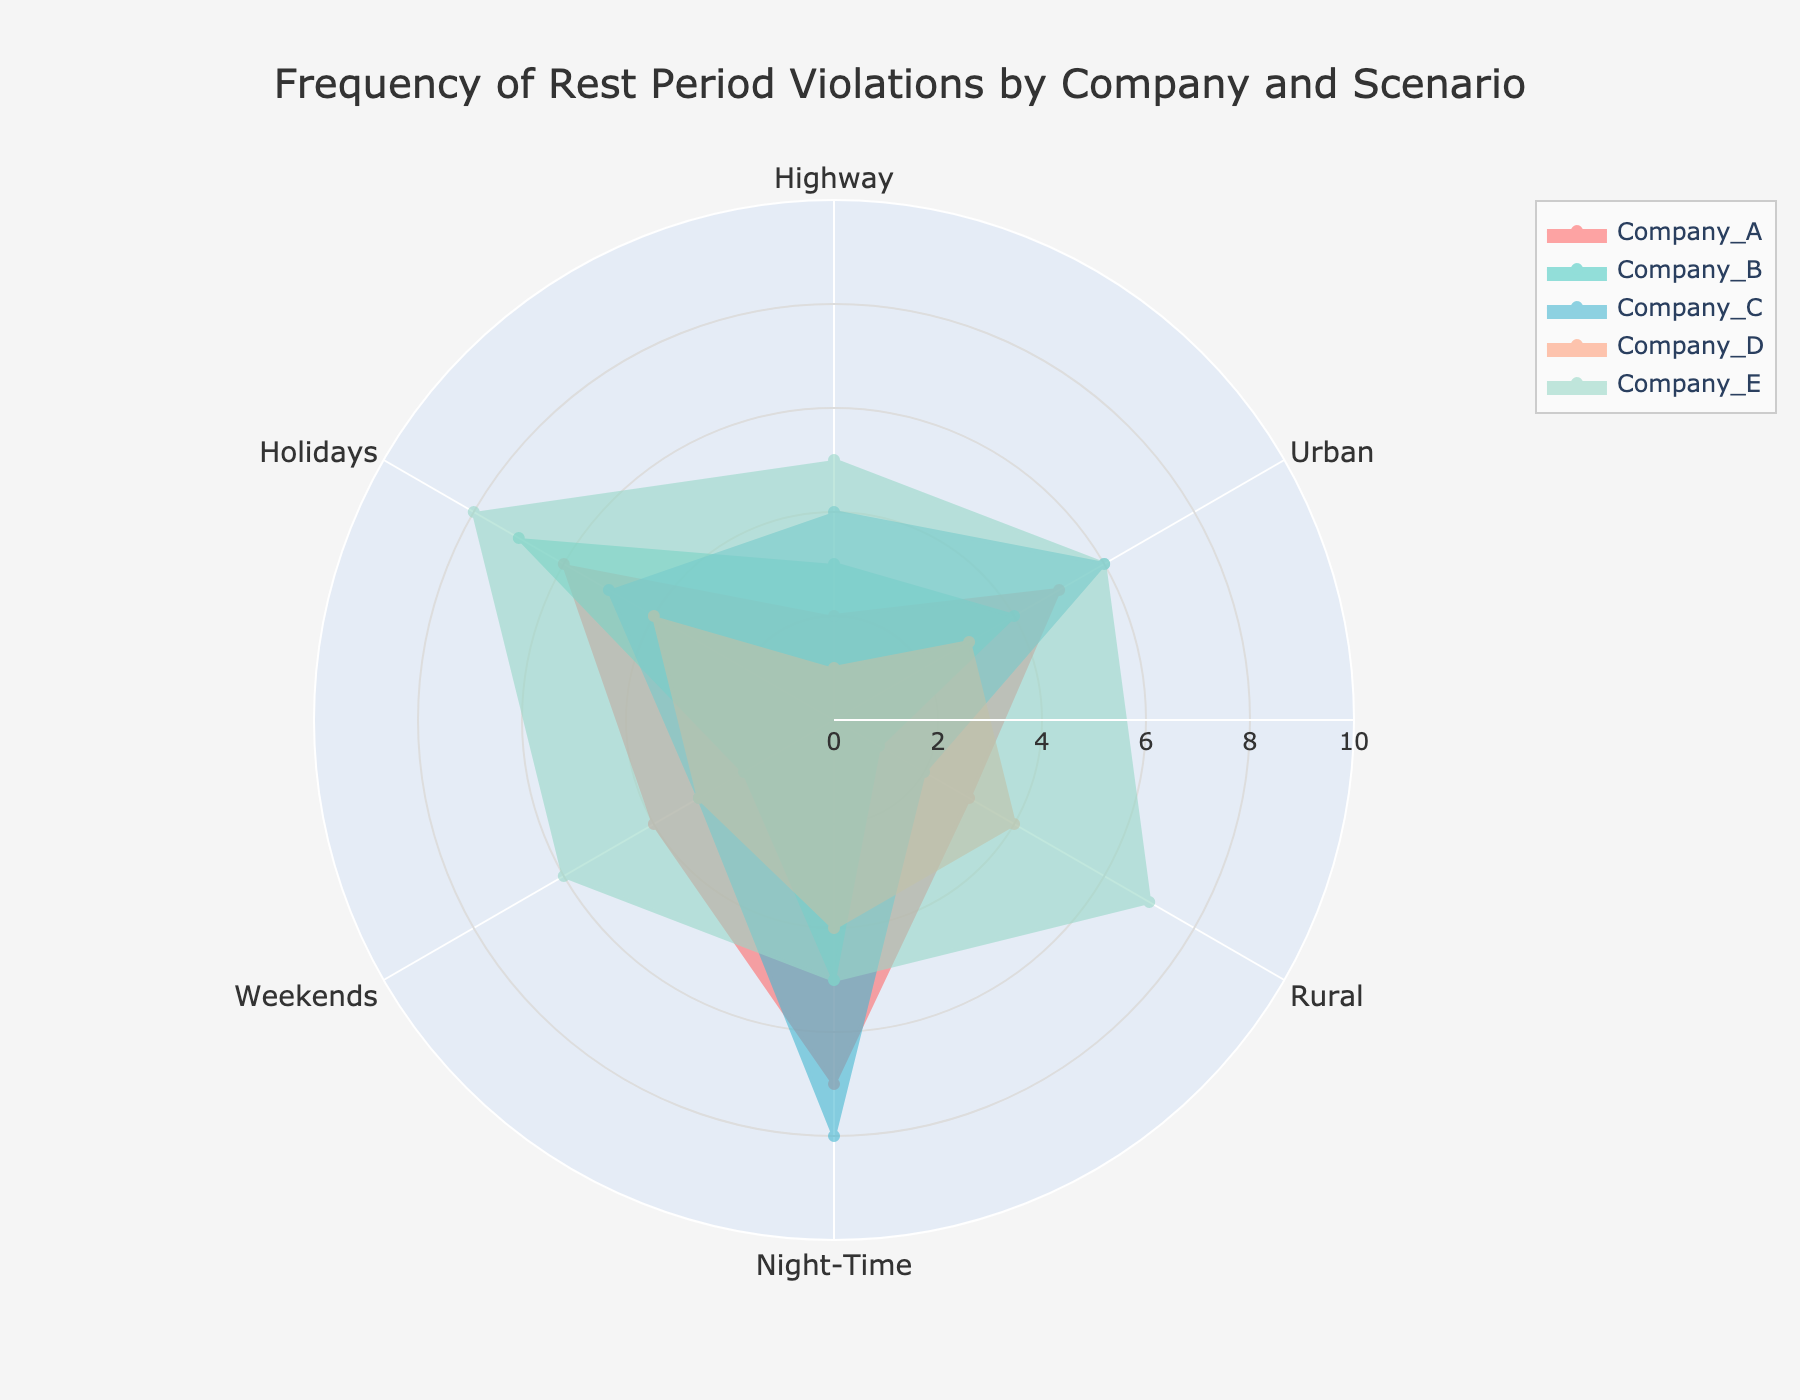what is the title of the radar chart? The title is typically located at the top of the plot. In this case, it reads "Frequency of Rest Period Violations by Company and Scenario."
Answer: Frequency of Rest Period Violations by Company and Scenario How many companies are represented in the radar chart? The radar chart includes five different companies, each represented by a distinct color. The companies are listed in the legend.
Answer: 5 Which company has the highest frequency of rest period violations in rural areas? Looking at the radial axis labeled "Rural" and comparing the values for each company, Company E has the highest point in this category.
Answer: Company E Which scenarios show the highest and lowest violations for Company A? For Company A, examine all the points on its trace. The highest violation is in "Night-Time" with a value of 7, and the lowest is in "Highway" with a value of 2.
Answer: Night-Time (highest), Highway (lowest) What is the average number of violations for Company C across all scenarios? Sum the values for Company C (4 + 6 + 2 + 8 + 3 + 5 = 28) and divide by the number of scenarios (6). The average is 28 / 6.
Answer: 4.67 How does the frequency of violations on weekends compare between Company B and Company D? For weekends, Company B has a value of 2 and Company D a value of 3. Company D has a higher frequency than Company B by 1 violation.
Answer: Company D has 1 more violation than Company B Which company shows the most uniform spread in the frequency of rest period violations across all scenarios? Company D exhibits the most uniform spread because its values across all categories show the least variation, ranging from 1 to 4.
Answer: Company D How does the frequency of rest period violations during holidays compare for Company A and Company C? For holidays, Company A has a value of 6 and Company C a value of 5. Company A has 1 more violation than Company C.
Answer: Company A has 1 more What is the range of violations for Company E across all scenarios? The range is calculated by subtracting the smallest value from the largest value. For Company E, the values range from 5 to 8. So, the range is 8 - 5.
Answer: 3 Which scenario sees the highest frequency of violations across all companies? Looking at all traces, the "Night-Time" category shows particularly high values for multiple companies, especially Company C with the highest value of 8.
Answer: Night-Time 